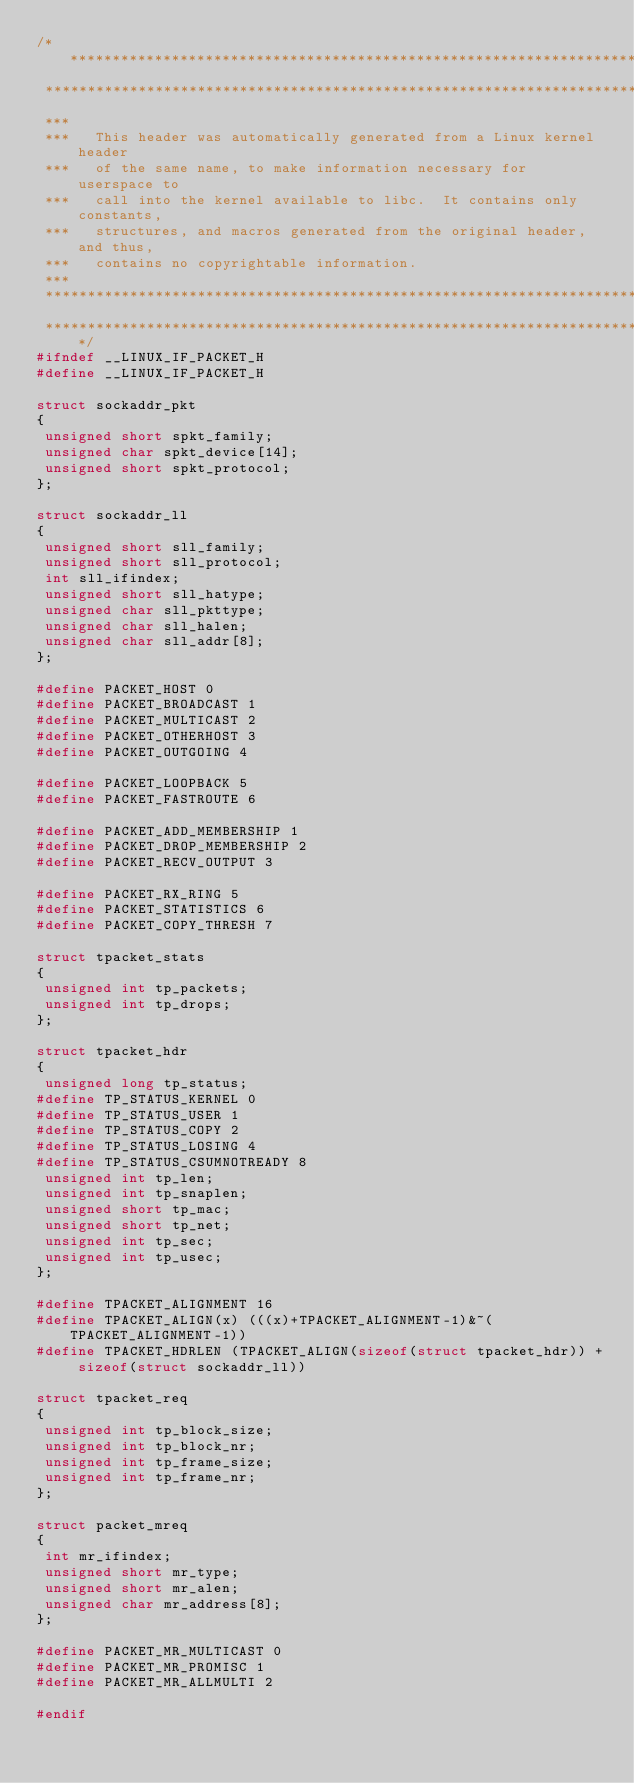<code> <loc_0><loc_0><loc_500><loc_500><_C_>/****************************************************************************
 ****************************************************************************
 ***
 ***   This header was automatically generated from a Linux kernel header
 ***   of the same name, to make information necessary for userspace to
 ***   call into the kernel available to libc.  It contains only constants,
 ***   structures, and macros generated from the original header, and thus,
 ***   contains no copyrightable information.
 ***
 ****************************************************************************
 ****************************************************************************/
#ifndef __LINUX_IF_PACKET_H
#define __LINUX_IF_PACKET_H

struct sockaddr_pkt
{
 unsigned short spkt_family;
 unsigned char spkt_device[14];
 unsigned short spkt_protocol;
};

struct sockaddr_ll
{
 unsigned short sll_family;
 unsigned short sll_protocol;
 int sll_ifindex;
 unsigned short sll_hatype;
 unsigned char sll_pkttype;
 unsigned char sll_halen;
 unsigned char sll_addr[8];
};

#define PACKET_HOST 0  
#define PACKET_BROADCAST 1  
#define PACKET_MULTICAST 2  
#define PACKET_OTHERHOST 3  
#define PACKET_OUTGOING 4  

#define PACKET_LOOPBACK 5  
#define PACKET_FASTROUTE 6  

#define PACKET_ADD_MEMBERSHIP 1
#define PACKET_DROP_MEMBERSHIP 2
#define PACKET_RECV_OUTPUT 3

#define PACKET_RX_RING 5
#define PACKET_STATISTICS 6
#define PACKET_COPY_THRESH 7

struct tpacket_stats
{
 unsigned int tp_packets;
 unsigned int tp_drops;
};

struct tpacket_hdr
{
 unsigned long tp_status;
#define TP_STATUS_KERNEL 0
#define TP_STATUS_USER 1
#define TP_STATUS_COPY 2
#define TP_STATUS_LOSING 4
#define TP_STATUS_CSUMNOTREADY 8
 unsigned int tp_len;
 unsigned int tp_snaplen;
 unsigned short tp_mac;
 unsigned short tp_net;
 unsigned int tp_sec;
 unsigned int tp_usec;
};

#define TPACKET_ALIGNMENT 16
#define TPACKET_ALIGN(x) (((x)+TPACKET_ALIGNMENT-1)&~(TPACKET_ALIGNMENT-1))
#define TPACKET_HDRLEN (TPACKET_ALIGN(sizeof(struct tpacket_hdr)) + sizeof(struct sockaddr_ll))

struct tpacket_req
{
 unsigned int tp_block_size;
 unsigned int tp_block_nr;
 unsigned int tp_frame_size;
 unsigned int tp_frame_nr;
};

struct packet_mreq
{
 int mr_ifindex;
 unsigned short mr_type;
 unsigned short mr_alen;
 unsigned char mr_address[8];
};

#define PACKET_MR_MULTICAST 0
#define PACKET_MR_PROMISC 1
#define PACKET_MR_ALLMULTI 2

#endif
</code> 